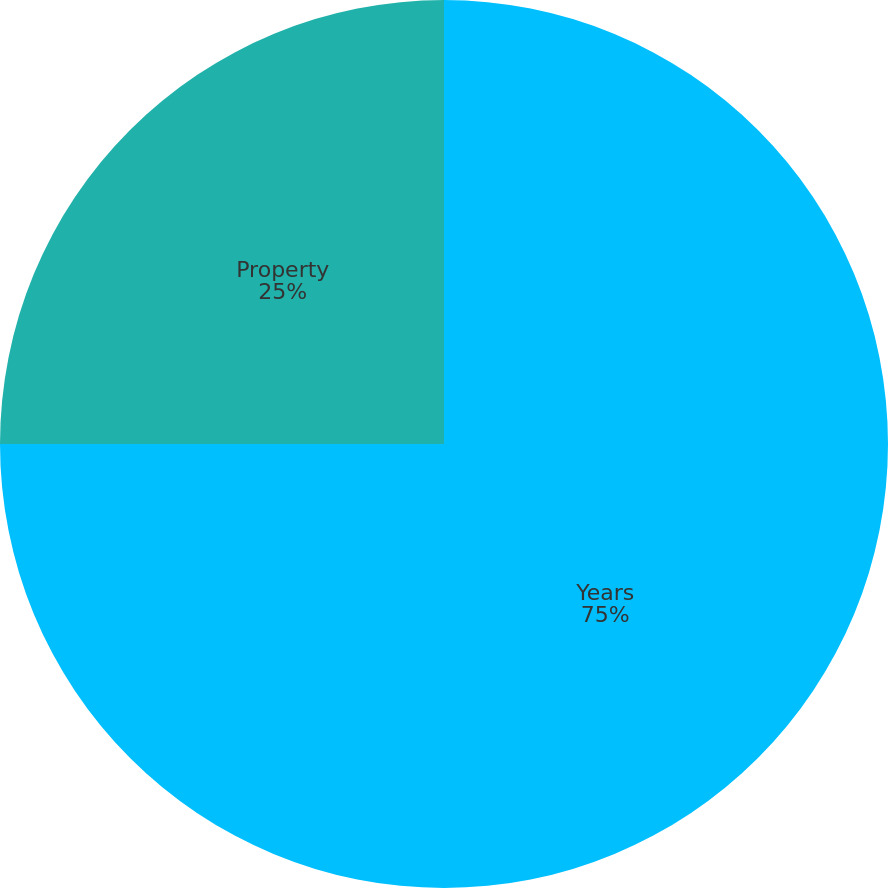Convert chart to OTSL. <chart><loc_0><loc_0><loc_500><loc_500><pie_chart><fcel>Years<fcel>Property<nl><fcel>75.0%<fcel>25.0%<nl></chart> 